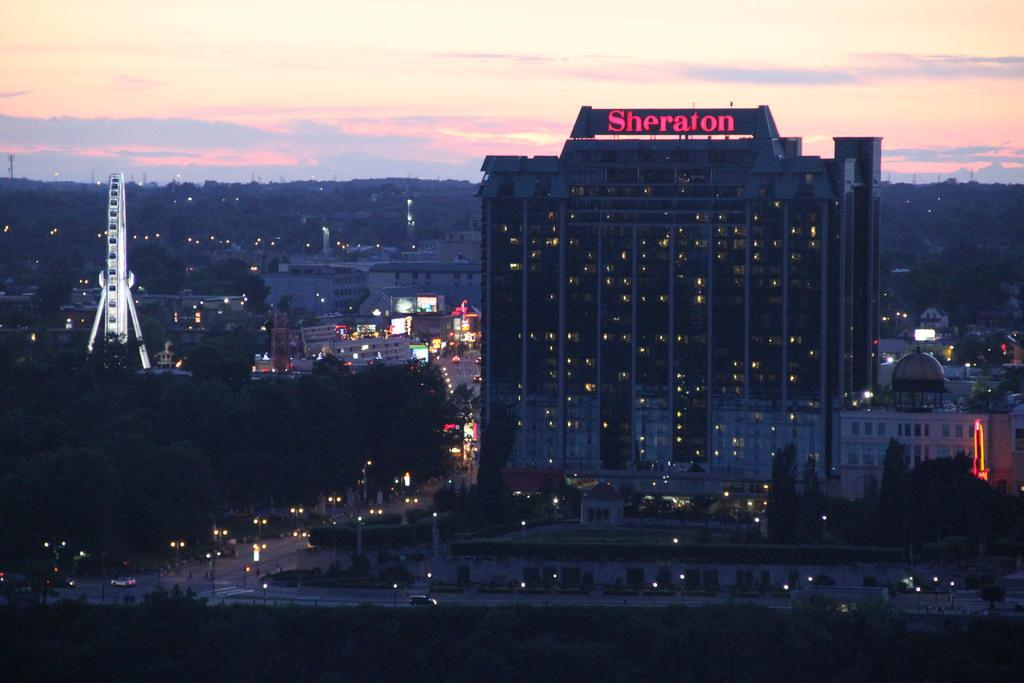What type of structures can be seen in the image? There are buildings in the image. What natural elements are present in the image? There are trees in the image. What artificial elements are present in the image? There are lights in the image. What time of day might the image depict? The image appears to depict a sunset. Where is the suit located in the image? There is no suit present in the image. What type of field can be seen in the image? There is no field present in the image. 